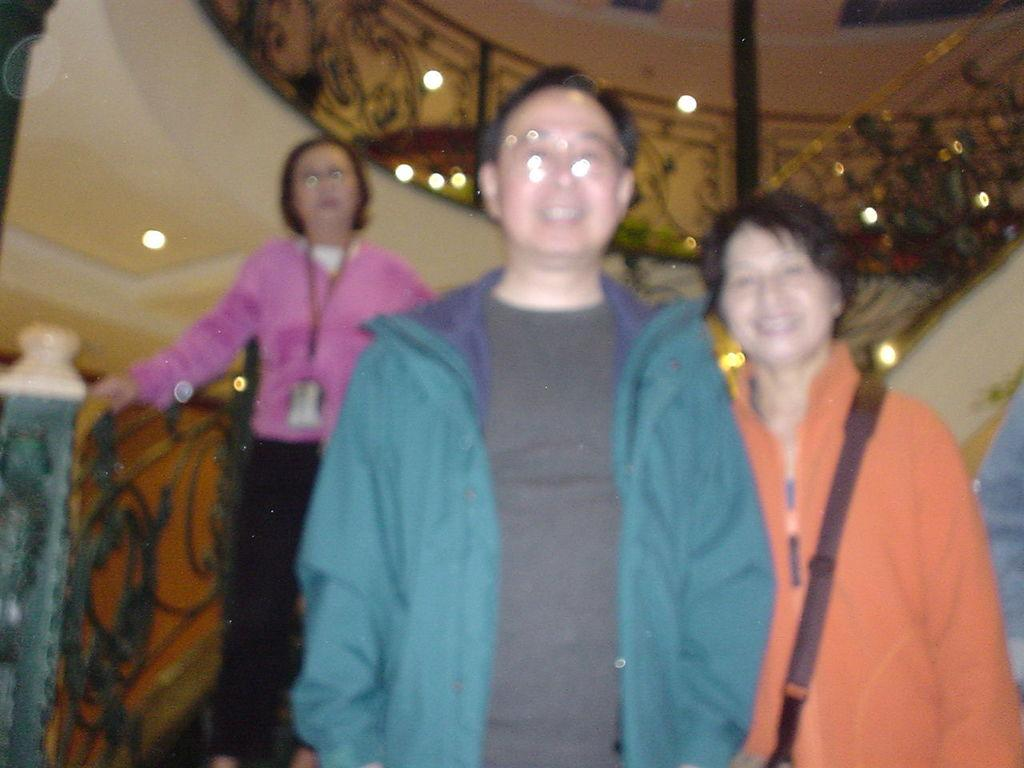How many people are in the image? There are three persons standing in the middle of the image. What are the expressions on the faces of the persons? The persons are smiling. What type of clothing are the persons wearing? The persons are wearing sweaters. What can be seen at the top of the image? There are lights visible at the top of the image. What type of pies are the persons holding in the image? There are no pies present in the image; the persons are not holding anything. What scientific experiment is being conducted in the image? There is no scientific experiment being conducted in the image; it simply shows three persons standing and smiling. 